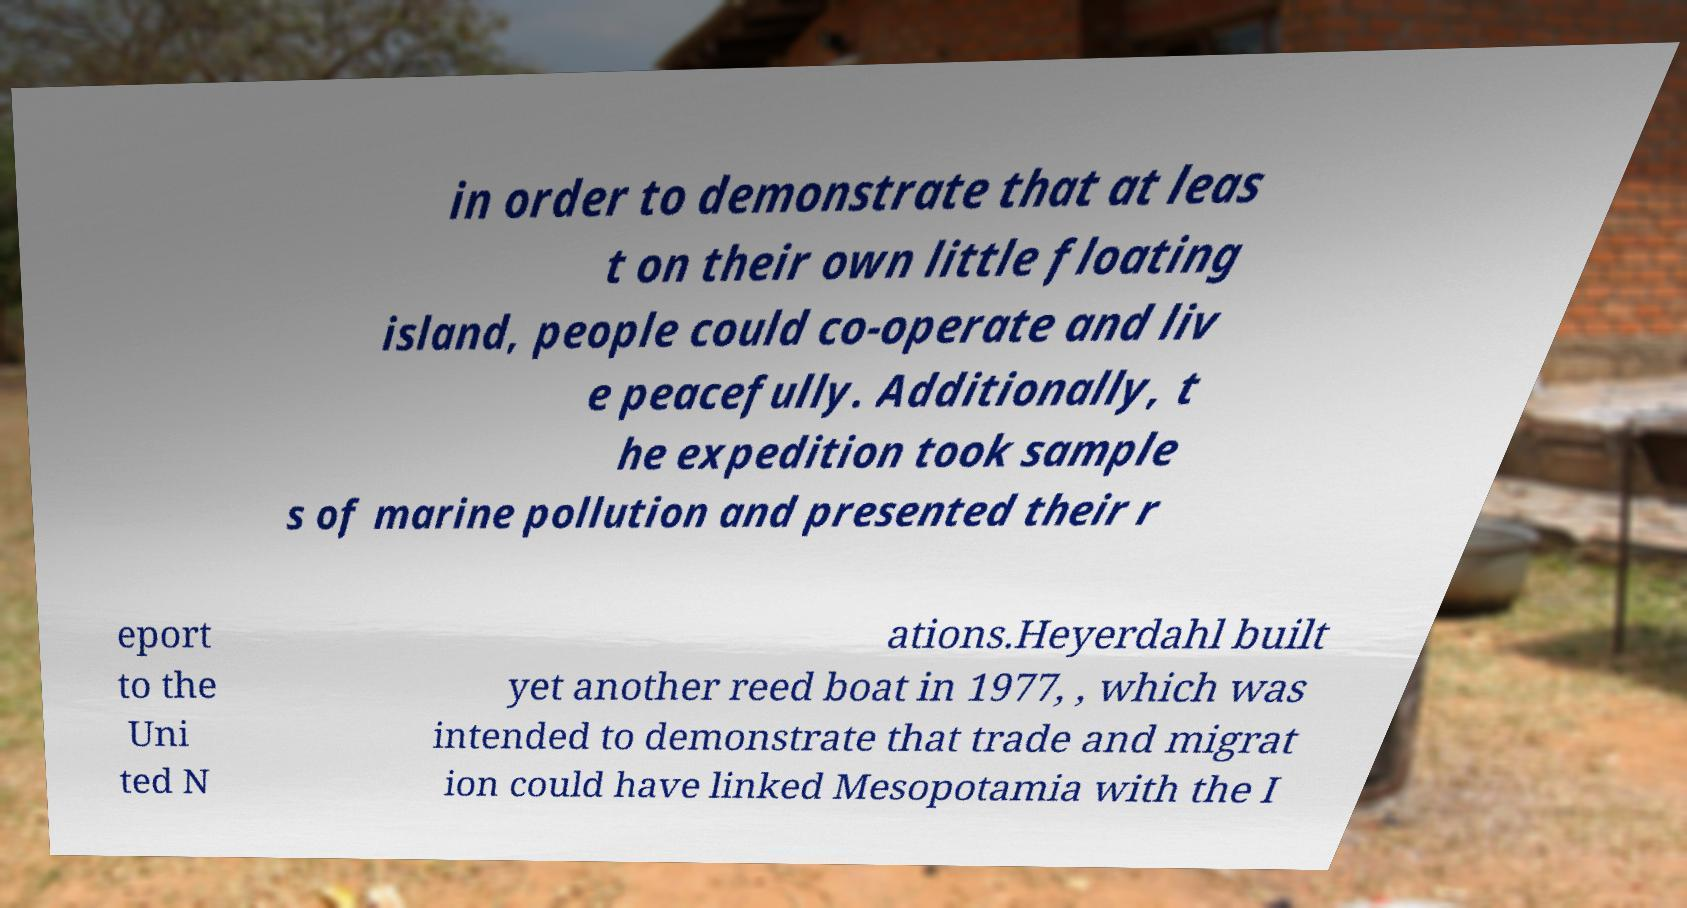For documentation purposes, I need the text within this image transcribed. Could you provide that? in order to demonstrate that at leas t on their own little floating island, people could co-operate and liv e peacefully. Additionally, t he expedition took sample s of marine pollution and presented their r eport to the Uni ted N ations.Heyerdahl built yet another reed boat in 1977, , which was intended to demonstrate that trade and migrat ion could have linked Mesopotamia with the I 